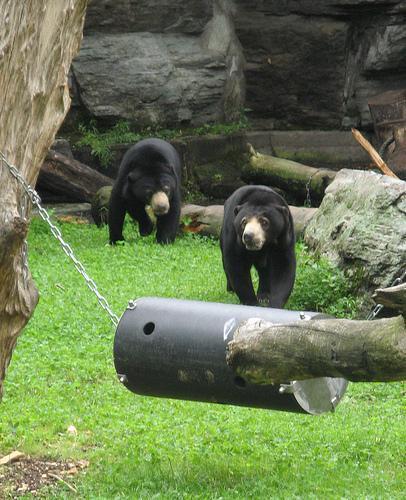How many bears are in the photo?
Give a very brief answer. 2. 